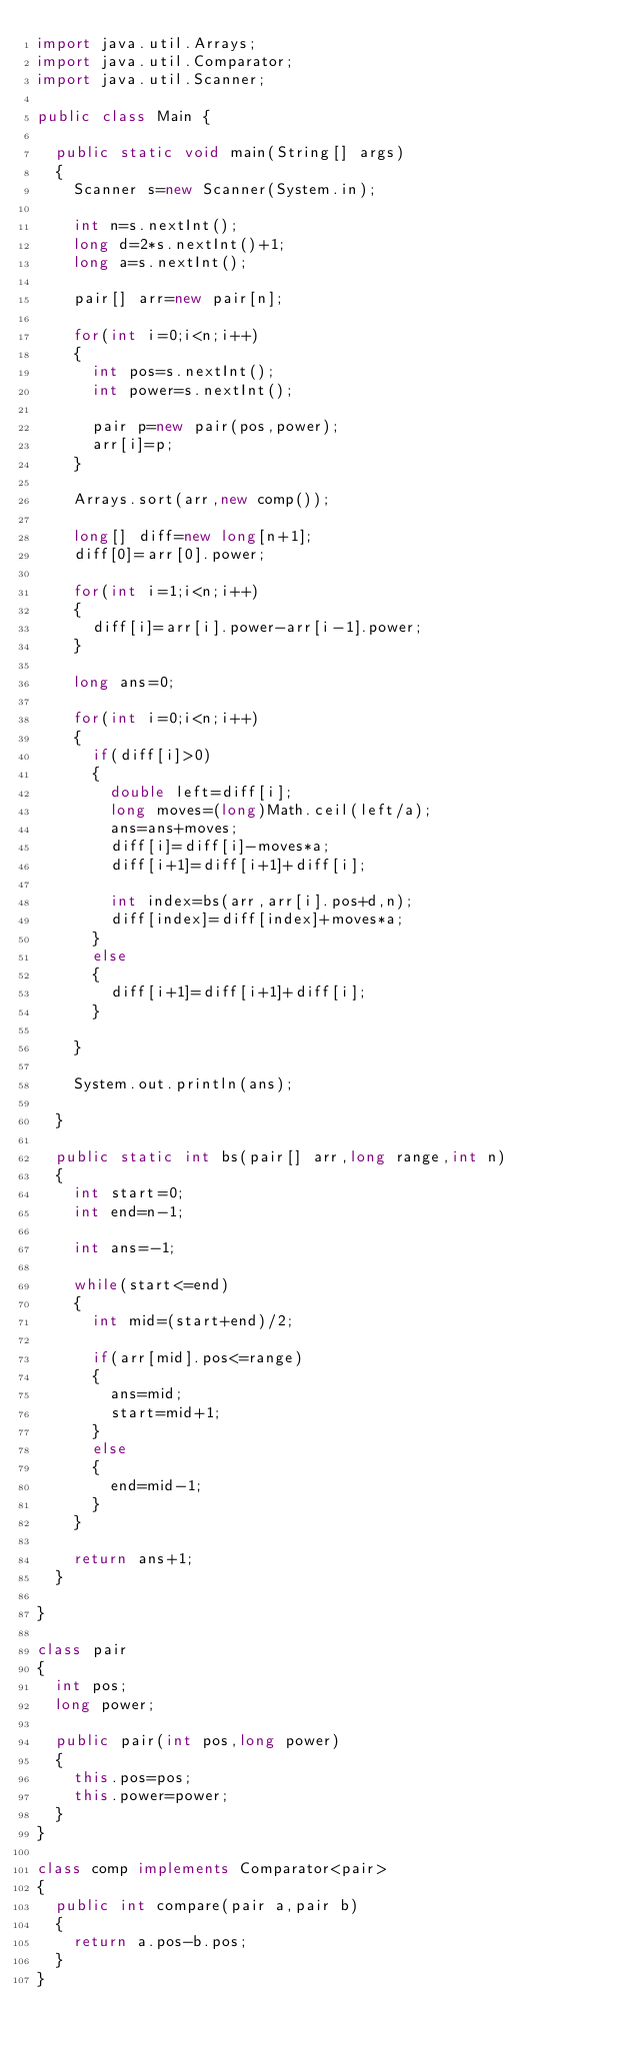Convert code to text. <code><loc_0><loc_0><loc_500><loc_500><_Java_>import java.util.Arrays;
import java.util.Comparator;
import java.util.Scanner;

public class Main {
	
	public static void main(String[] args)
	{
		Scanner s=new Scanner(System.in);
		
		int n=s.nextInt();
		long d=2*s.nextInt()+1;
		long a=s.nextInt();
		
		pair[] arr=new pair[n];
		
		for(int i=0;i<n;i++)
		{
			int pos=s.nextInt();
			int power=s.nextInt();
			
			pair p=new pair(pos,power);
			arr[i]=p;
		}
		
		Arrays.sort(arr,new comp());
		
		long[] diff=new long[n+1];
		diff[0]=arr[0].power;
		
		for(int i=1;i<n;i++)
		{
			diff[i]=arr[i].power-arr[i-1].power;
		}
		
		long ans=0;
		
		for(int i=0;i<n;i++)
		{
			if(diff[i]>0)
			{
				double left=diff[i];
				long moves=(long)Math.ceil(left/a);
				ans=ans+moves;
				diff[i]=diff[i]-moves*a;
				diff[i+1]=diff[i+1]+diff[i];
				
				int index=bs(arr,arr[i].pos+d,n);
				diff[index]=diff[index]+moves*a;
			}
			else
			{
				diff[i+1]=diff[i+1]+diff[i];
			}
			
		}
		
		System.out.println(ans);
		
	}
	
	public static int bs(pair[] arr,long range,int n)
	{
		int start=0;
		int end=n-1;
		
		int ans=-1;
		
		while(start<=end)
		{
			int mid=(start+end)/2;
			
			if(arr[mid].pos<=range)
			{
				ans=mid;
				start=mid+1;
			}
			else
			{
				end=mid-1;
			}
		}
		
		return ans+1;
	}
	
}

class pair
{
	int pos;
	long power;
	
	public pair(int pos,long power)
	{
		this.pos=pos;
		this.power=power;
	}
}

class comp implements Comparator<pair>
{
	public int compare(pair a,pair b)
	{
		return a.pos-b.pos;
	}
}</code> 